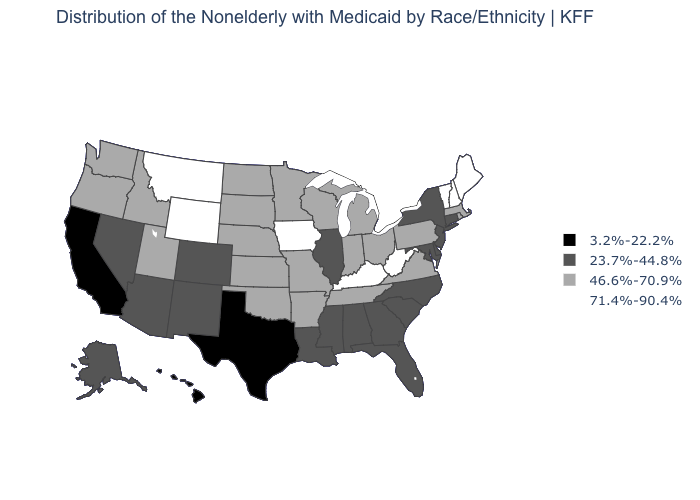What is the value of California?
Concise answer only. 3.2%-22.2%. What is the highest value in the USA?
Write a very short answer. 71.4%-90.4%. How many symbols are there in the legend?
Quick response, please. 4. Which states have the lowest value in the USA?
Be succinct. California, Hawaii, Texas. Does Maryland have the same value as Massachusetts?
Write a very short answer. No. What is the highest value in states that border Missouri?
Be succinct. 71.4%-90.4%. What is the highest value in the USA?
Give a very brief answer. 71.4%-90.4%. What is the highest value in states that border Kentucky?
Write a very short answer. 71.4%-90.4%. Does New Hampshire have the lowest value in the USA?
Concise answer only. No. Does the map have missing data?
Give a very brief answer. No. Which states hav the highest value in the MidWest?
Give a very brief answer. Iowa. Among the states that border Texas , which have the lowest value?
Quick response, please. Louisiana, New Mexico. Name the states that have a value in the range 3.2%-22.2%?
Give a very brief answer. California, Hawaii, Texas. How many symbols are there in the legend?
Concise answer only. 4. Does the first symbol in the legend represent the smallest category?
Answer briefly. Yes. 